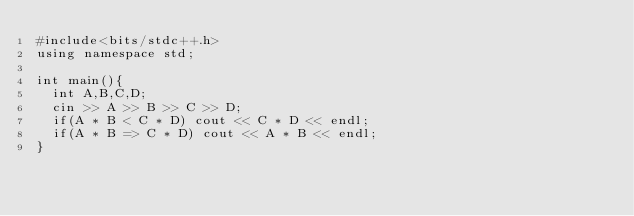<code> <loc_0><loc_0><loc_500><loc_500><_C++_>#include<bits/stdc++.h>
using namespace std;

int main(){
  int A,B,C,D;
  cin >> A >> B >> C >> D;
  if(A * B < C * D) cout << C * D << endl;
  if(A * B => C * D) cout << A * B << endl;
}</code> 